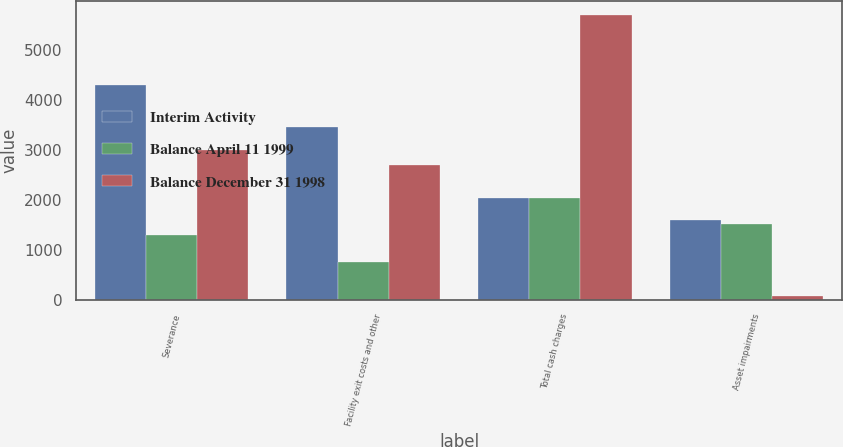<chart> <loc_0><loc_0><loc_500><loc_500><stacked_bar_chart><ecel><fcel>Severance<fcel>Facility exit costs and other<fcel>Total cash charges<fcel>Asset impairments<nl><fcel>Interim Activity<fcel>4283<fcel>3447<fcel>2038<fcel>1596<nl><fcel>Balance April 11 1999<fcel>1290<fcel>748<fcel>2038<fcel>1510<nl><fcel>Balance December 31 1998<fcel>2993<fcel>2699<fcel>5692<fcel>86<nl></chart> 